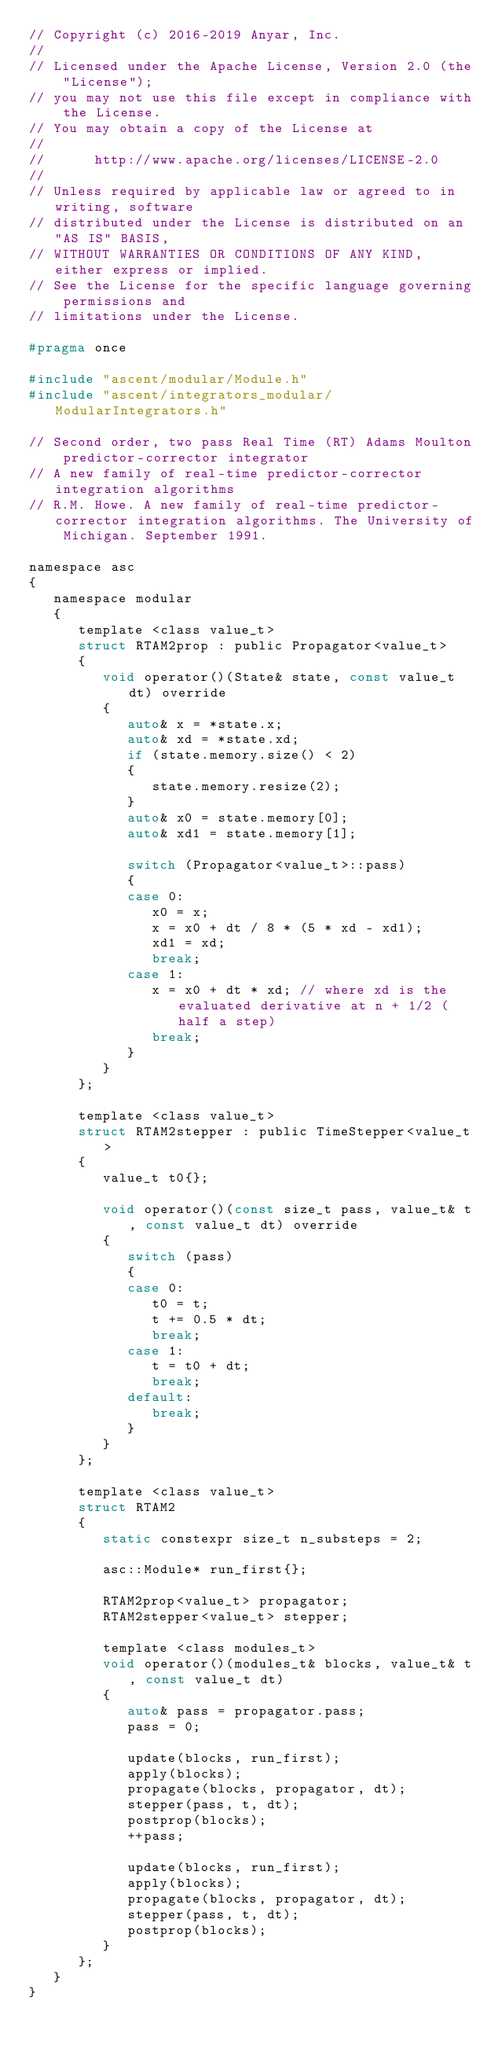<code> <loc_0><loc_0><loc_500><loc_500><_C_>// Copyright (c) 2016-2019 Anyar, Inc.
// 
// Licensed under the Apache License, Version 2.0 (the "License");
// you may not use this file except in compliance with the License.
// You may obtain a copy of the License at
// 
//      http://www.apache.org/licenses/LICENSE-2.0
// 
// Unless required by applicable law or agreed to in writing, software
// distributed under the License is distributed on an "AS IS" BASIS,
// WITHOUT WARRANTIES OR CONDITIONS OF ANY KIND, either express or implied.
// See the License for the specific language governing permissions and
// limitations under the License.

#pragma once

#include "ascent/modular/Module.h"
#include "ascent/integrators_modular/ModularIntegrators.h"

// Second order, two pass Real Time (RT) Adams Moulton predictor-corrector integrator
// A new family of real-time predictor-corrector integration algorithms
// R.M. Howe. A new family of real-time predictor-corrector integration algorithms. The University of Michigan. September 1991.

namespace asc
{
   namespace modular
   {
      template <class value_t>
      struct RTAM2prop : public Propagator<value_t>
      {
         void operator()(State& state, const value_t dt) override
         {
            auto& x = *state.x;
            auto& xd = *state.xd;
            if (state.memory.size() < 2)
            {
               state.memory.resize(2);
            }
            auto& x0 = state.memory[0];
            auto& xd1 = state.memory[1];

            switch (Propagator<value_t>::pass)
            {
            case 0:
               x0 = x;
               x = x0 + dt / 8 * (5 * xd - xd1);
               xd1 = xd;
               break;
            case 1:
               x = x0 + dt * xd; // where xd is the evaluated derivative at n + 1/2 (half a step)
               break;
            }
         }
      };

      template <class value_t>
      struct RTAM2stepper : public TimeStepper<value_t>
      {
         value_t t0{};

         void operator()(const size_t pass, value_t& t, const value_t dt) override
         {
            switch (pass)
            {
            case 0:
               t0 = t;
               t += 0.5 * dt;
               break;
            case 1:
               t = t0 + dt;
               break;
            default:
               break;
            }
         }
      };

      template <class value_t>
      struct RTAM2
      {
         static constexpr size_t n_substeps = 2;
         
         asc::Module* run_first{};

         RTAM2prop<value_t> propagator;
         RTAM2stepper<value_t> stepper;

         template <class modules_t>
         void operator()(modules_t& blocks, value_t& t, const value_t dt)
         {
            auto& pass = propagator.pass;
            pass = 0;
            
            update(blocks, run_first);
            apply(blocks);
            propagate(blocks, propagator, dt);
            stepper(pass, t, dt);
            postprop(blocks);
            ++pass;

            update(blocks, run_first);
            apply(blocks);
            propagate(blocks, propagator, dt);
            stepper(pass, t, dt);
            postprop(blocks);
         }
      };
   }
}
</code> 